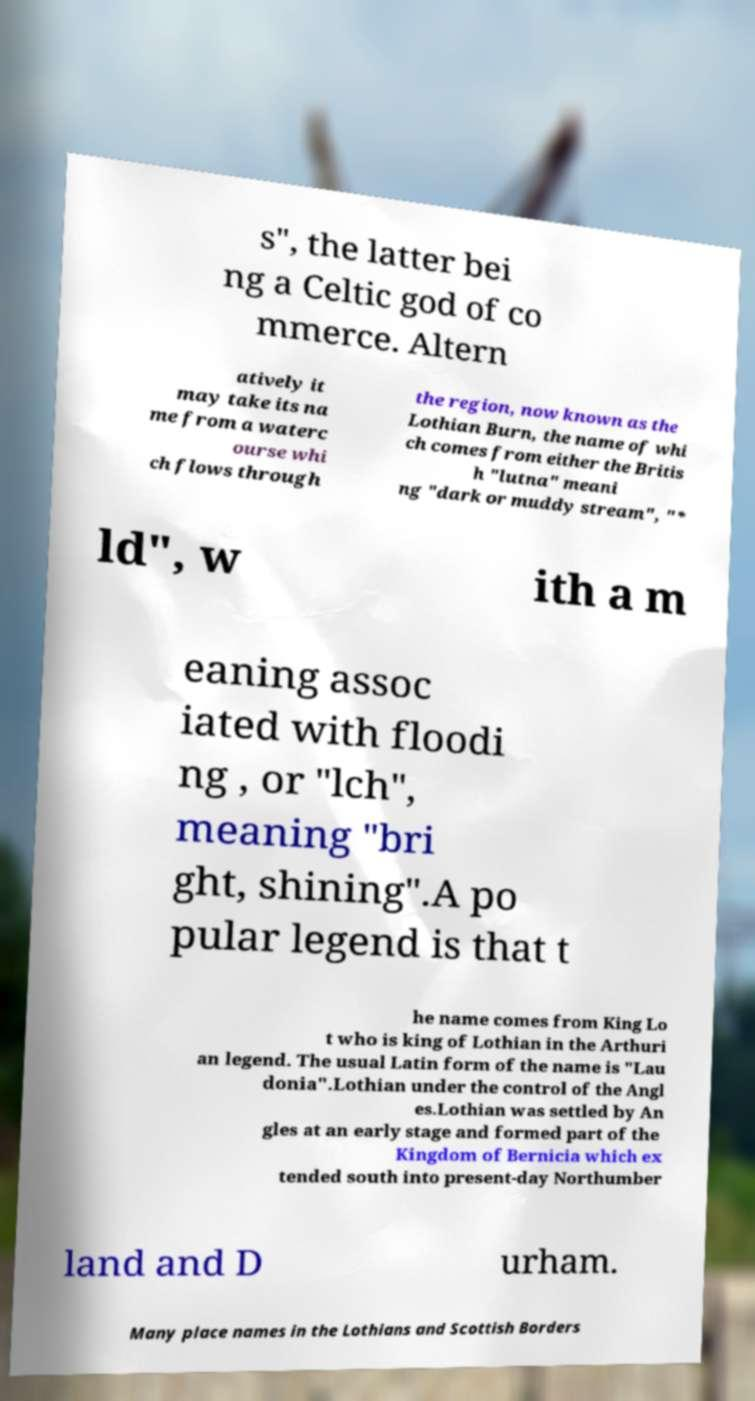What messages or text are displayed in this image? I need them in a readable, typed format. s", the latter bei ng a Celtic god of co mmerce. Altern atively it may take its na me from a waterc ourse whi ch flows through the region, now known as the Lothian Burn, the name of whi ch comes from either the Britis h "lutna" meani ng "dark or muddy stream", "* ld", w ith a m eaning assoc iated with floodi ng , or "lch", meaning "bri ght, shining".A po pular legend is that t he name comes from King Lo t who is king of Lothian in the Arthuri an legend. The usual Latin form of the name is "Lau donia".Lothian under the control of the Angl es.Lothian was settled by An gles at an early stage and formed part of the Kingdom of Bernicia which ex tended south into present-day Northumber land and D urham. Many place names in the Lothians and Scottish Borders 